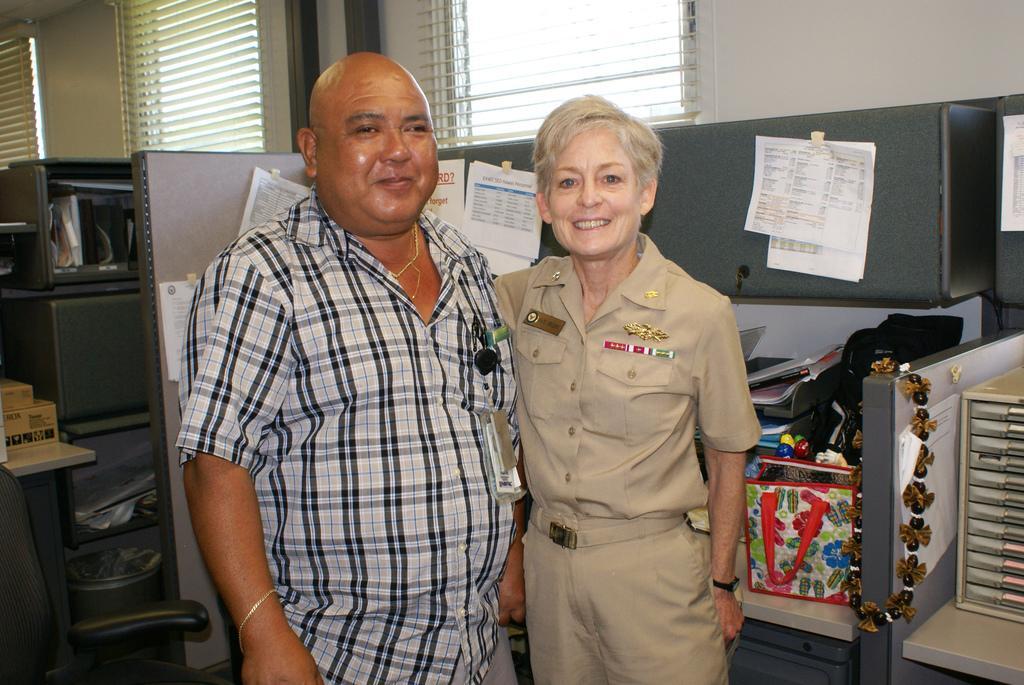Can you describe this image briefly? In this image we can see a man and woman is standing. Man is wearing shirt and the woman is wearing uniform. Left side of the image one cupboard and black color chair is there. Right side of the image, on table things are there. Background of the image window is present. 